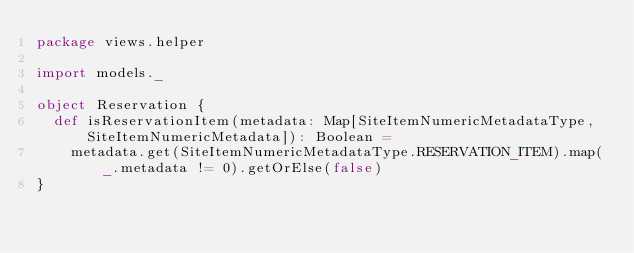Convert code to text. <code><loc_0><loc_0><loc_500><loc_500><_Scala_>package views.helper

import models._

object Reservation {
  def isReservationItem(metadata: Map[SiteItemNumericMetadataType, SiteItemNumericMetadata]): Boolean =
    metadata.get(SiteItemNumericMetadataType.RESERVATION_ITEM).map(_.metadata != 0).getOrElse(false)
}
</code> 